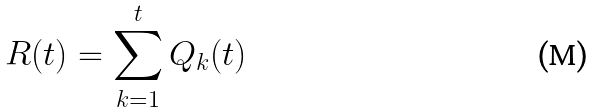<formula> <loc_0><loc_0><loc_500><loc_500>R ( t ) = \sum _ { k = 1 } ^ { t } Q _ { k } ( t )</formula> 